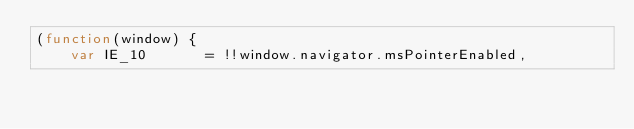<code> <loc_0><loc_0><loc_500><loc_500><_JavaScript_>(function(window) {
	var IE_10		= !!window.navigator.msPointerEnabled,</code> 